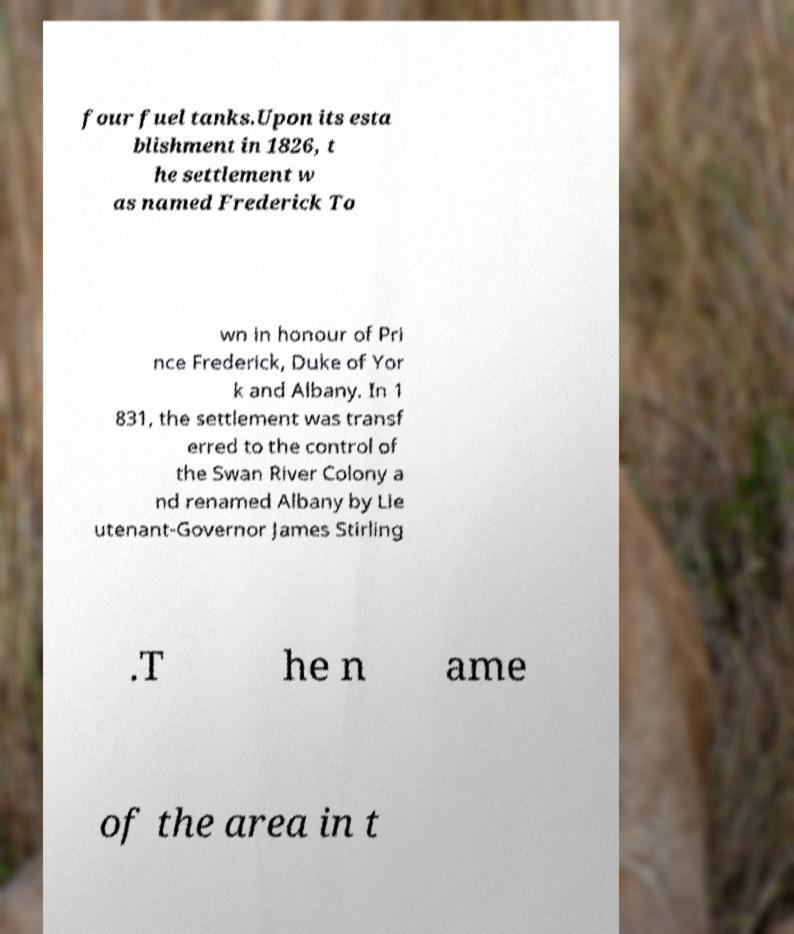Please identify and transcribe the text found in this image. four fuel tanks.Upon its esta blishment in 1826, t he settlement w as named Frederick To wn in honour of Pri nce Frederick, Duke of Yor k and Albany. In 1 831, the settlement was transf erred to the control of the Swan River Colony a nd renamed Albany by Lie utenant-Governor James Stirling .T he n ame of the area in t 